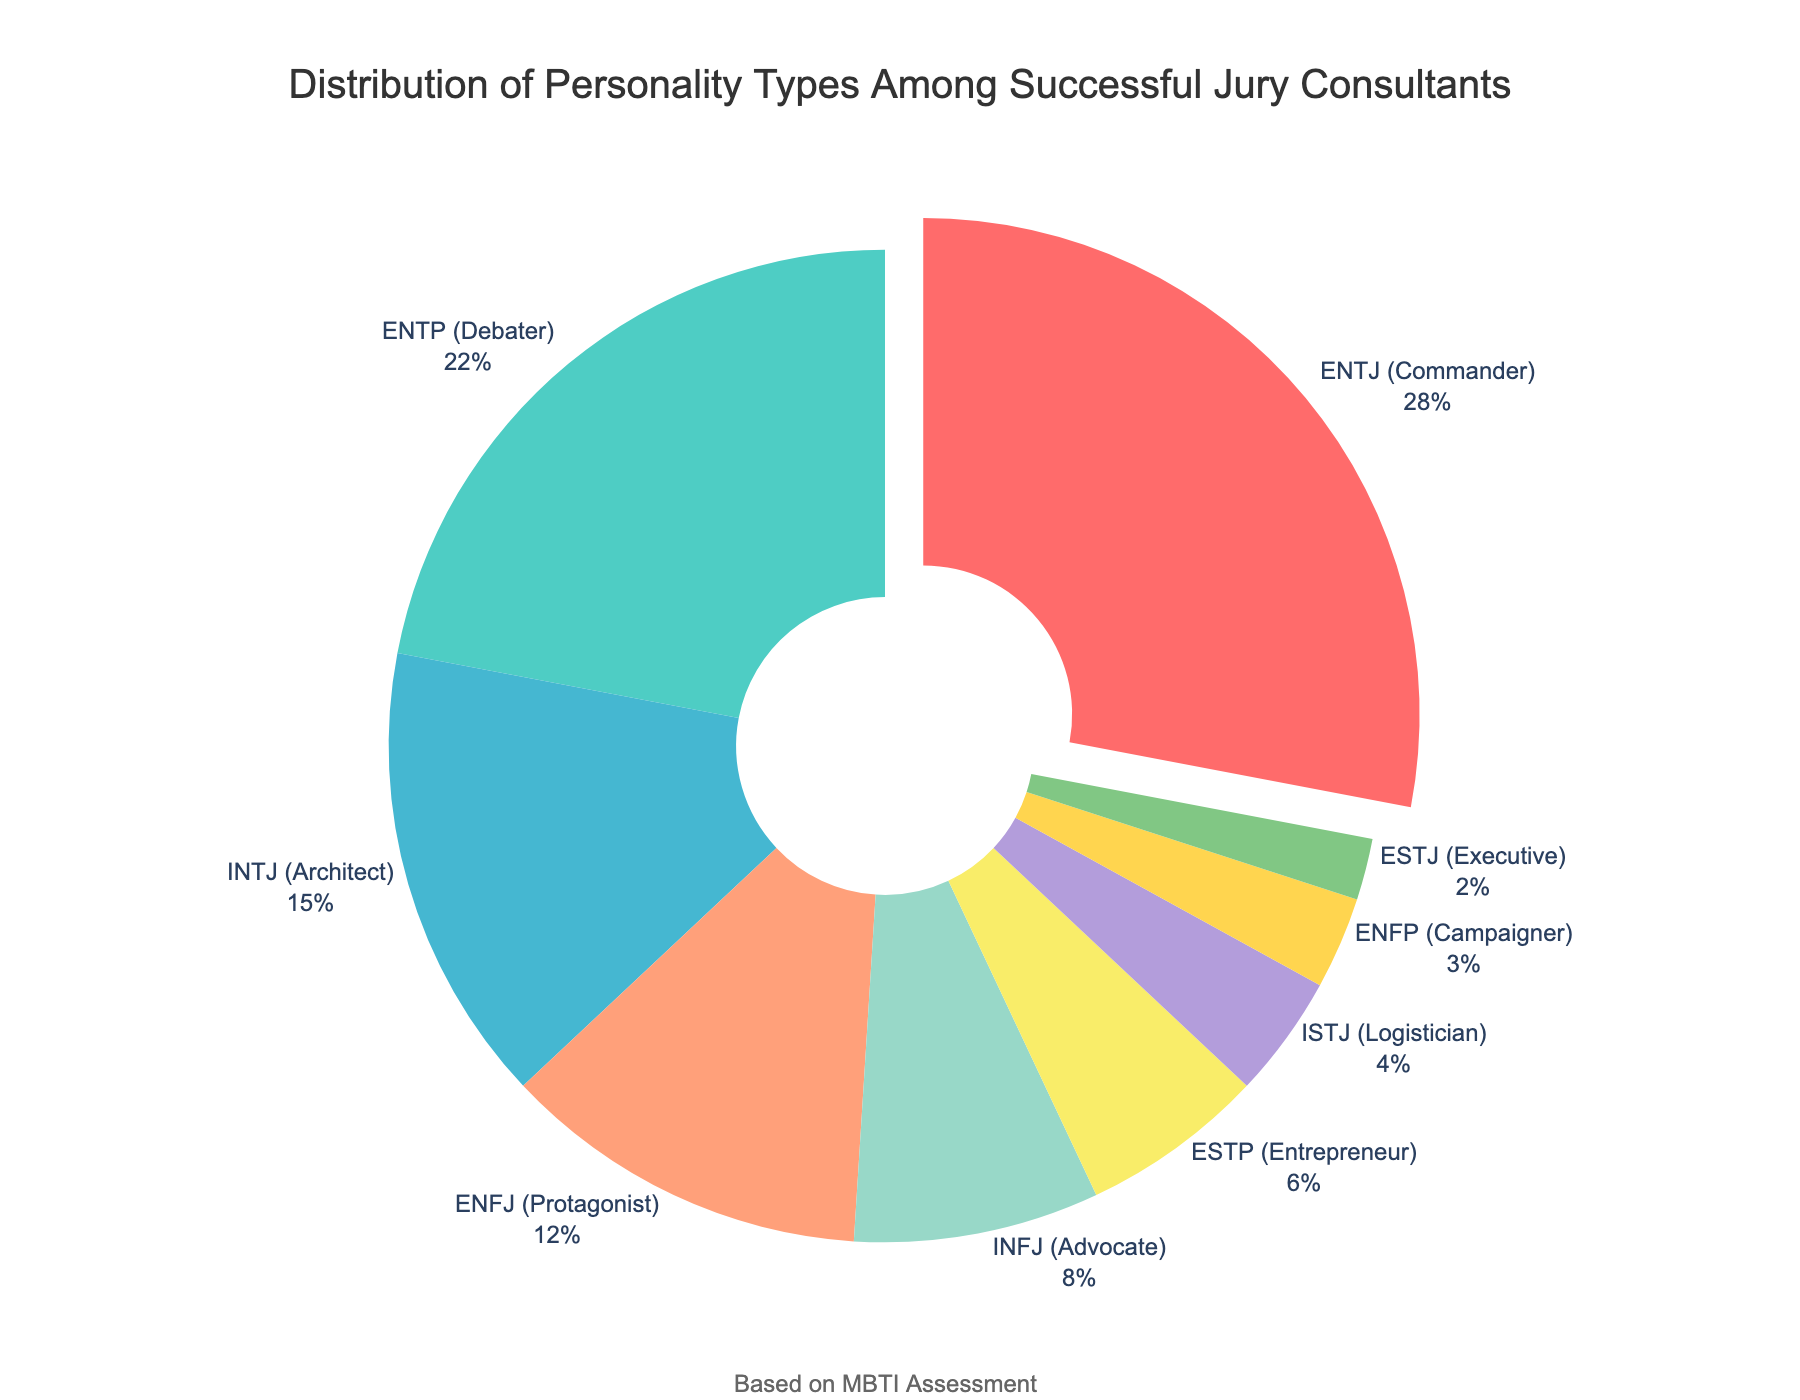What is the most common personality type among successful jury consultants? The most common personality type is shown by the segment pulled out from the pie chart. In this case, it is "ENTJ (Commander)" which has the largest percentage value of 28%.
Answer: ENTJ (Commander) Which two personality types together make up half of the distribution? To determine this, add the percentages of the top two personality types: "ENTJ (Commander)" at 28% and "ENTP (Debater)" at 22%. Together, they make up 28% + 22% = 50%.
Answer: ENTJ (Commander) and ENTP (Debater) How many different personality types are represented in the pie chart? Count the number of distinct segments in the pie chart. The chart shows nine different personality types.
Answer: 9 What is the total percentage of introverted types (INTJ, INFJ, and ISTJ)? Sum the percentages of all introverted types: INTJ (15%), INFJ (8%), and ISTJ (4%): 15% + 8% + 4% = 27%.
Answer: 27% Which personality type is represented by a green color in the chart? By identifying the segments and their corresponding colors, "ENTP (Debater)" is represented by green.
Answer: ENTP (Debater) What is the difference in percentage between the third most common and the least common personality types? Find the percentages of the third most common type (INTJ - 15%) and the least common type (ESTJ - 2%). The difference is 15% - 2% = 13%.
Answer: 13% Which one is rarer, ENFP or ESTP, and by how much? Compare the percentages of ENFP (3%) and ESTP (6%): ESTP is more common, and the difference is 6% - 3% = 3%.
Answer: ENFP by 3% What is the combined percentage of all personality types that have a percentage less than 10%? Add the percentages of all types less than 10%: INFJ (8%), ESTP (6%), ISTJ (4%), ENFP (3%), and ESTJ (2%). The total is 8% + 6% + 4% + 3% + 2% = 23%.
Answer: 23% If you group ENFJ and ENFP together, what will be their total percentage? Sum the percentages of ENFJ (12%) and ENFP (3%): the total is 12% + 3% = 15%.
Answer: 15% Which personality type has the smallest percentage and what is it? Look at the segment with the smallest area. The "ESTJ (Executive)" has the smallest percentage at 2%.
Answer: ESTJ (Executive) 2% 